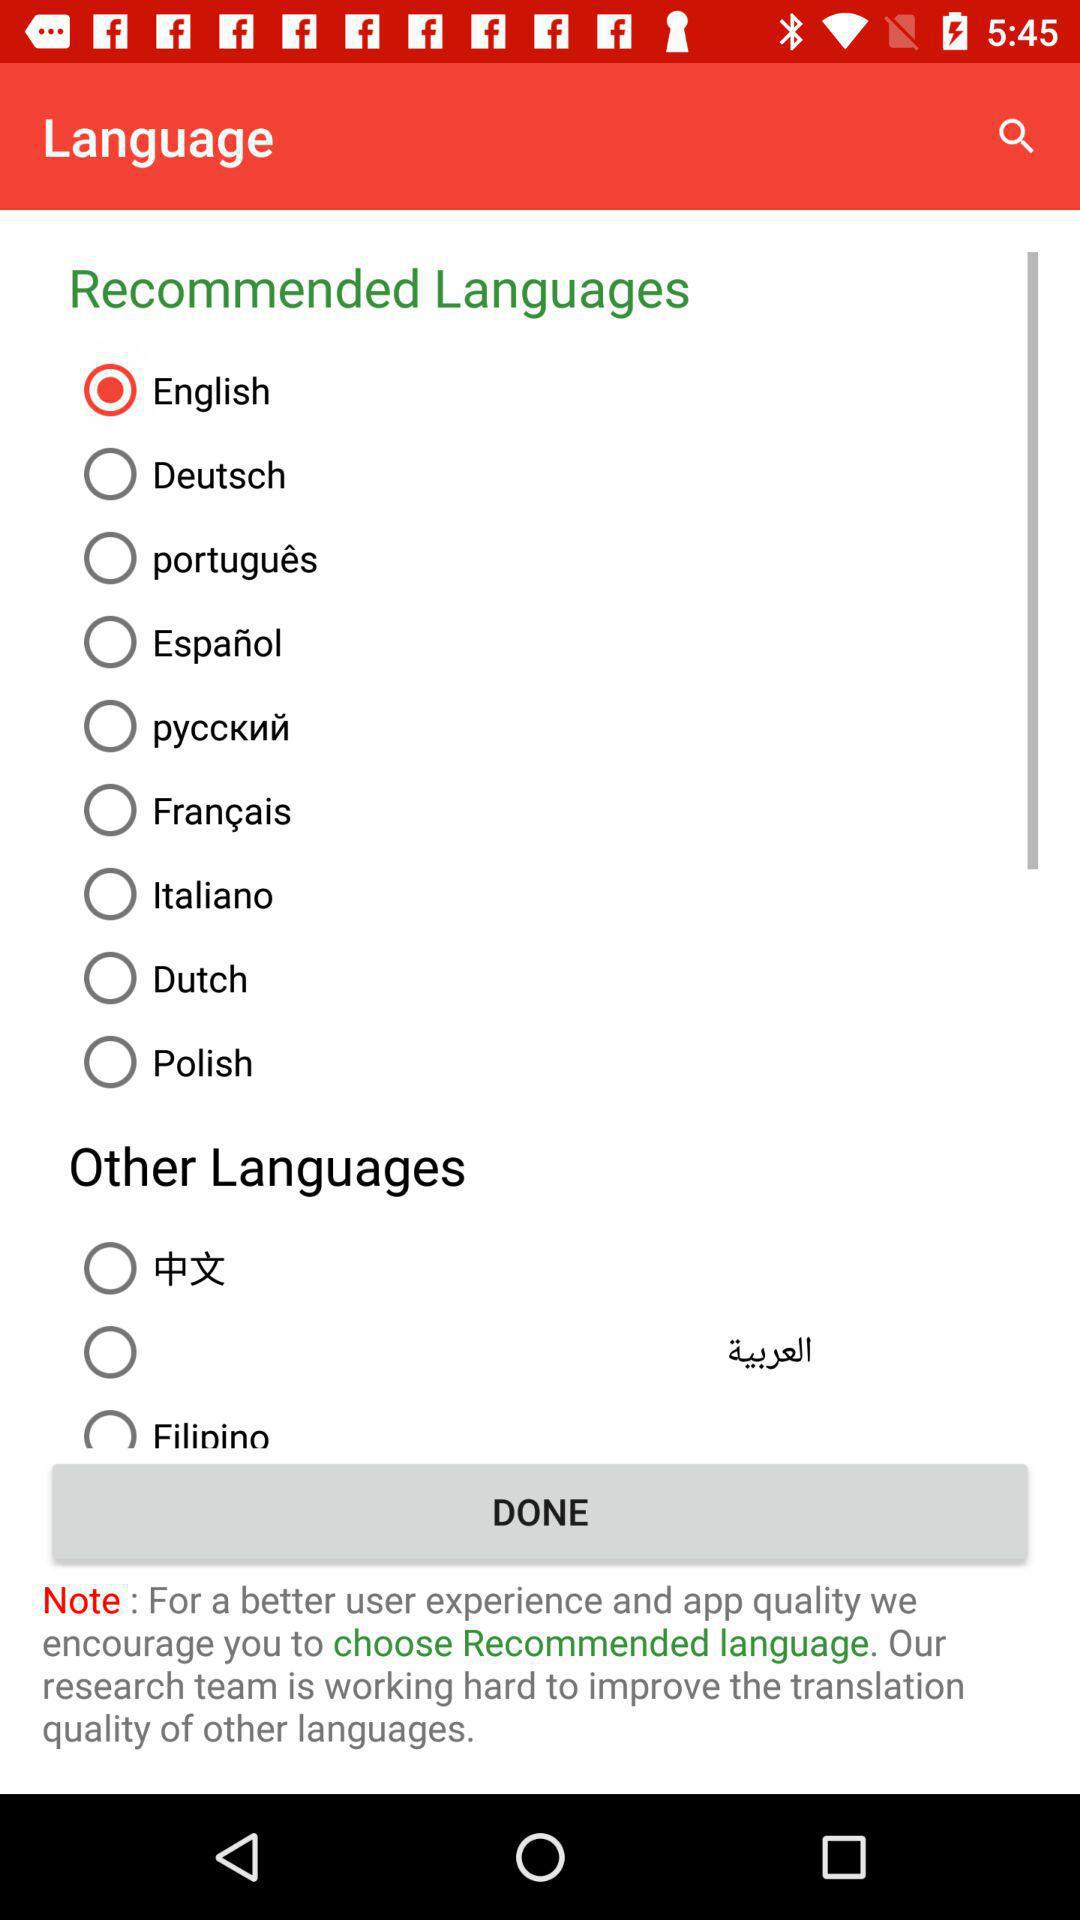How many languages are in the Other Languages section?
Answer the question using a single word or phrase. 3 